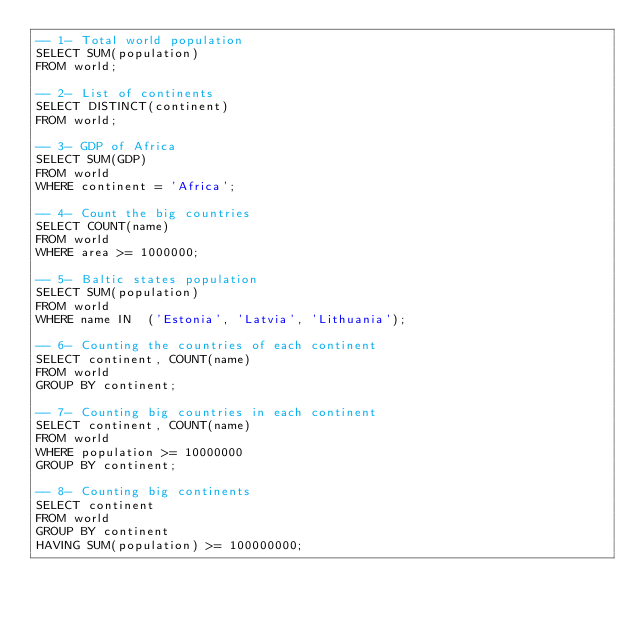<code> <loc_0><loc_0><loc_500><loc_500><_SQL_>-- 1- Total world population
SELECT SUM(population)
FROM world;

-- 2- List of continents
SELECT DISTINCT(continent)
FROM world;

-- 3- GDP of Africa
SELECT SUM(GDP)
FROM world
WHERE continent = 'Africa';

-- 4- Count the big countries
SELECT COUNT(name)
FROM world
WHERE area >= 1000000;

-- 5- Baltic states population
SELECT SUM(population)
FROM world
WHERE name IN  ('Estonia', 'Latvia', 'Lithuania');

-- 6- Counting the countries of each continent
SELECT continent, COUNT(name)
FROM world
GROUP BY continent;

-- 7- Counting big countries in each continent
SELECT continent, COUNT(name)
FROM world
WHERE population >= 10000000
GROUP BY continent;

-- 8- Counting big continents
SELECT continent
FROM world
GROUP BY continent
HAVING SUM(population) >= 100000000;</code> 